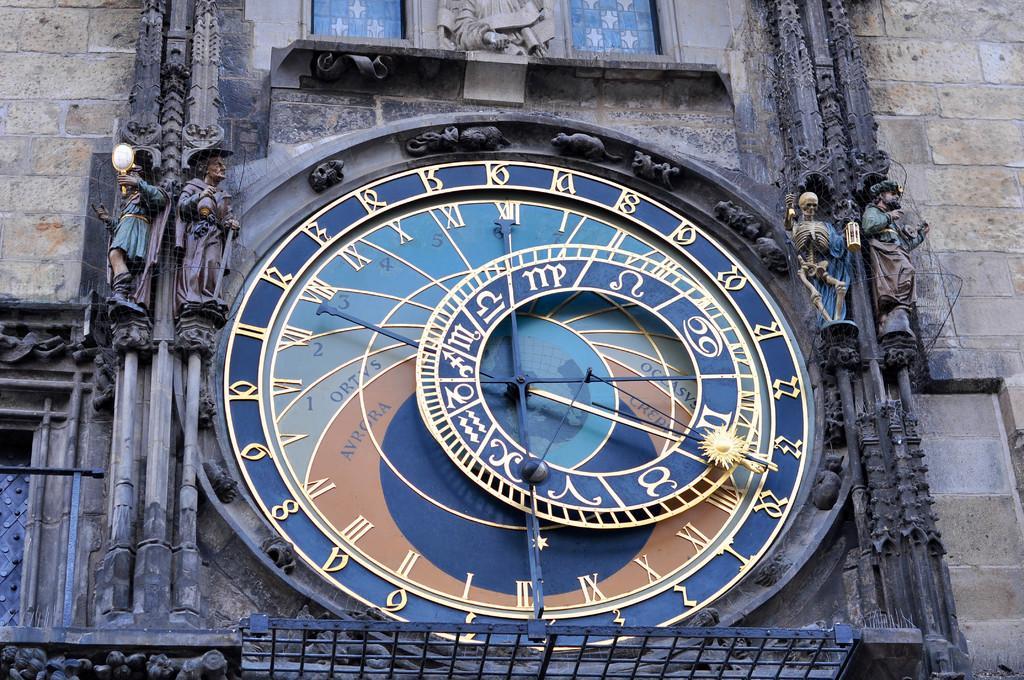Could you give a brief overview of what you see in this image? In the middle of the image, there is a clock on the wall of the building. On both sides of this building, there are statues on the wall. Above this clock, there is a statue on the wall. 